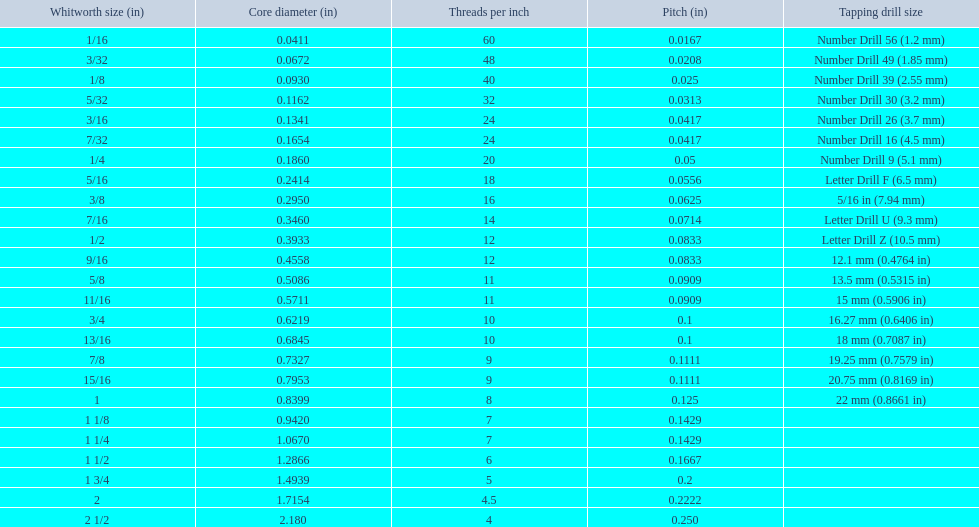What's the core diameter for a 1/16 whitworth? 0.0411. Which whitworth measurement has an identical pitch to a 1/2? 9/16. Which size corresponds to the same thread count as a 3/16 whitworth? 7/32. 